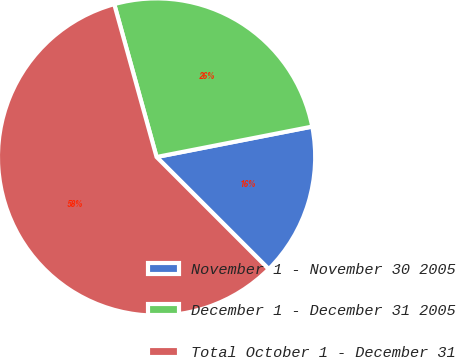Convert chart. <chart><loc_0><loc_0><loc_500><loc_500><pie_chart><fcel>November 1 - November 30 2005<fcel>December 1 - December 31 2005<fcel>Total October 1 - December 31<nl><fcel>15.57%<fcel>26.23%<fcel>58.2%<nl></chart> 